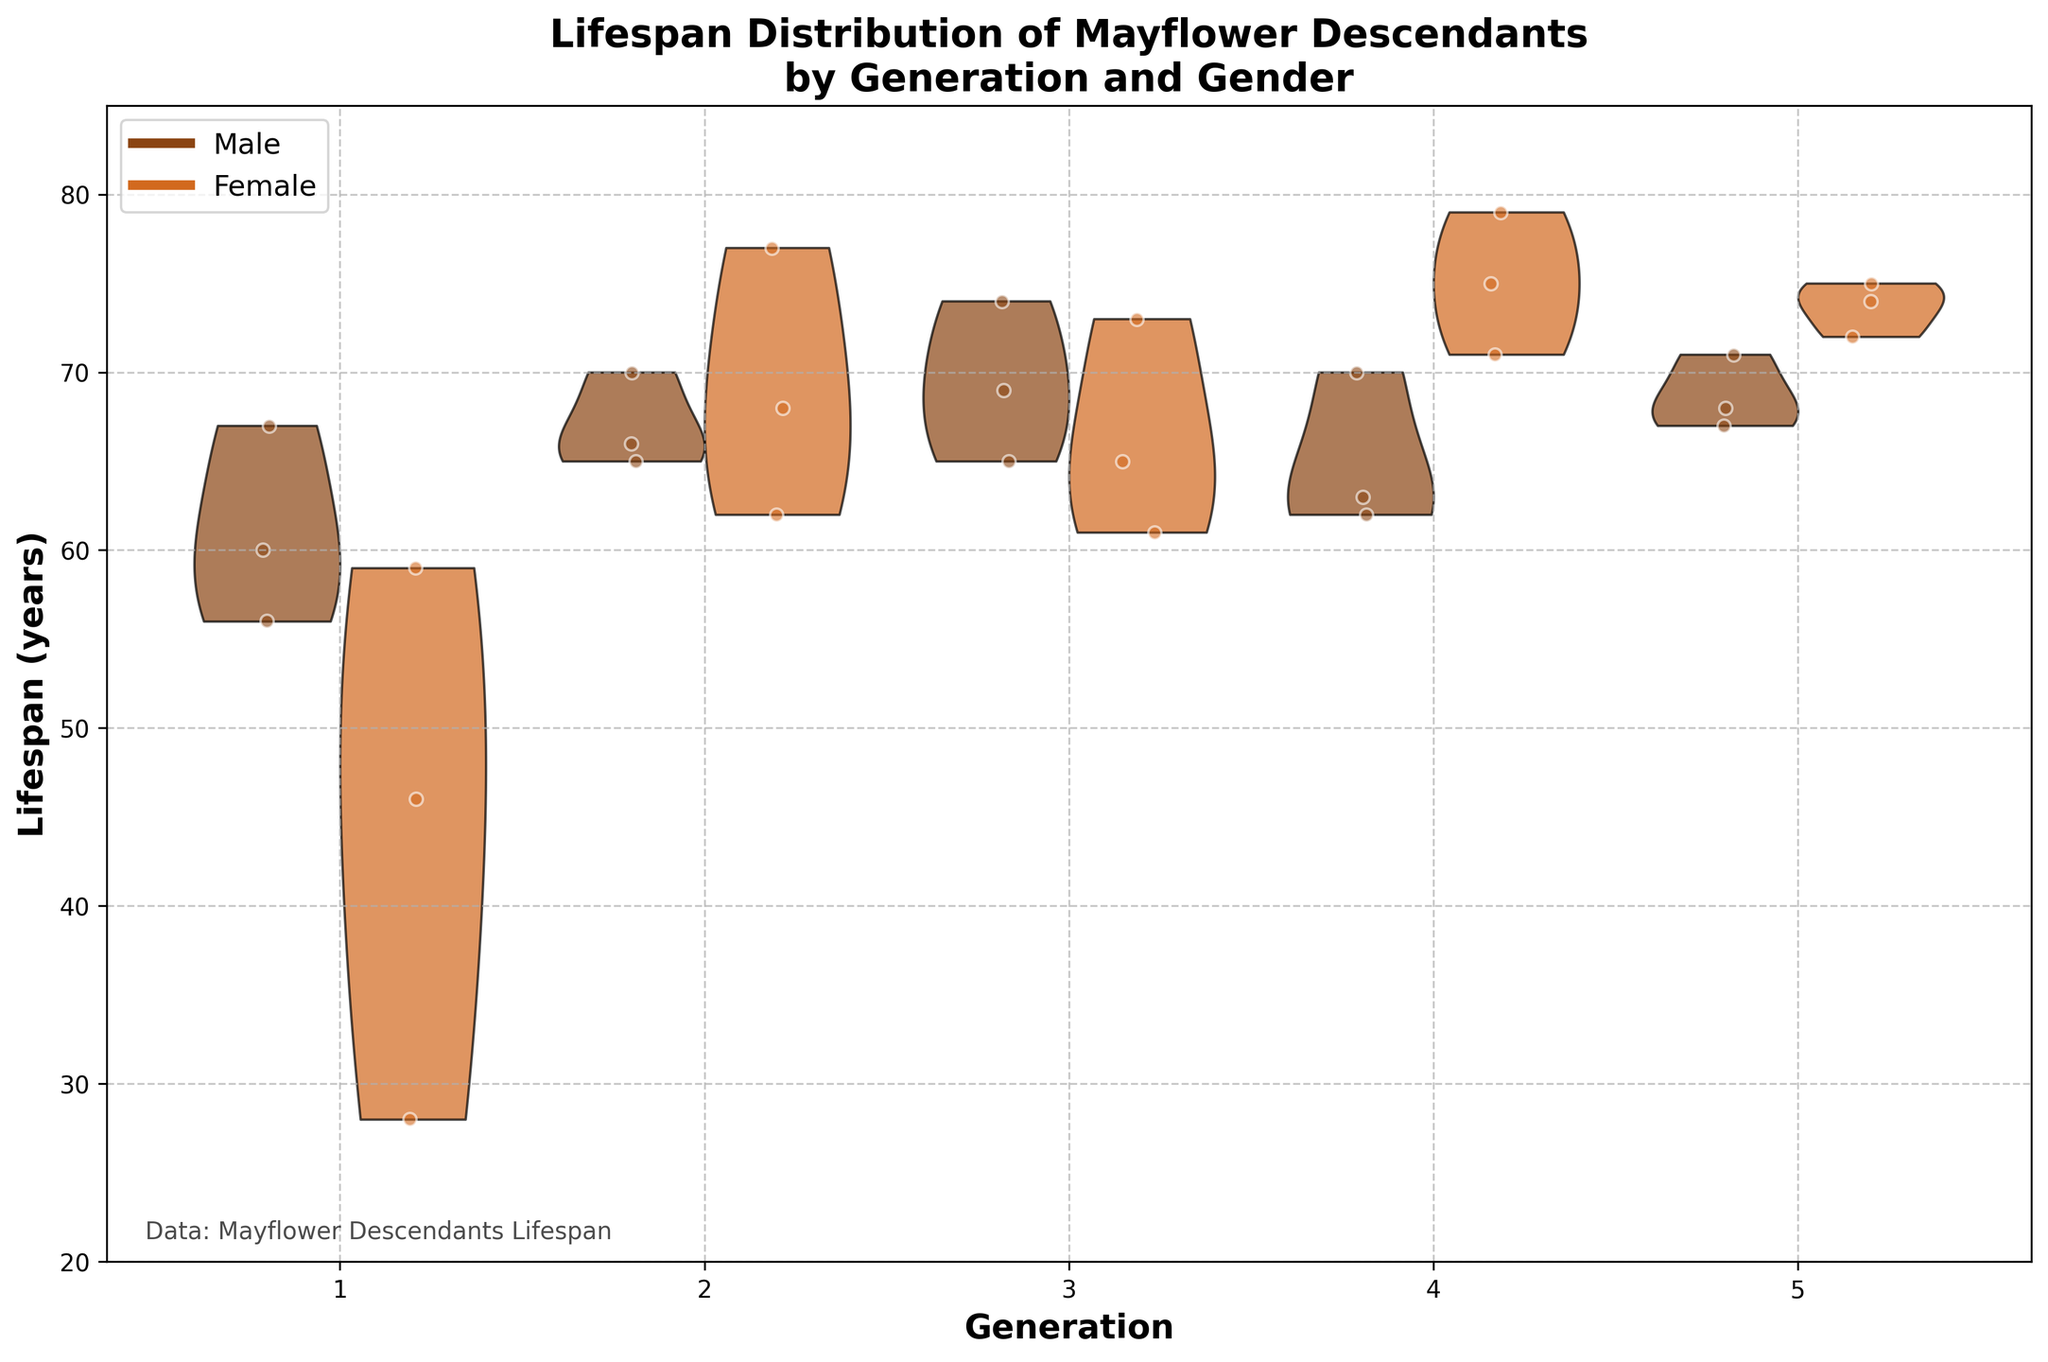What is the title of the plot? The title of the plot is prominently displayed at the top of the figure. It reads "Lifespan Distribution of Mayflower Descendants by Generation and Gender."
Answer: Lifespan Distribution of Mayflower Descendants by Generation and Gender How many generations are displayed on the x-axis? The x-axis labels each generation, starting from 1 and ending at 5, indicating that there are five generations included in the plot.
Answer: 5 Which generation has the highest median lifespan for females? By examining the distribution of the lifespan for females across each generation, the plot shows that Generation 4 has the highest median lifespan. This is suggested by the highest central peak in the female part of the violin plot for Generation 4.
Answer: Generation 4 In which generation do males have a higher median lifespan compared to females? Looking at the central peaks of the violin plots for both genders, one can identify that Generation 1 has a higher median lifespan for males compared to females based on the position of the peaks.
Answer: Generation 1 How do the lifespans of male and female descendants compare in Generation 3? By comparing the violin plots for Generation 3, both male and female lifespans seem to have a similar distribution with close medians, but the peaks for both genders are almost aligned, suggesting a similar median lifespan.
Answer: Similar On average, do males or females live longer across all generations? By visually assessing the center of each violin for both genders across all generations, females generally appear to have a higher central tendency (median) than males. This can be concluded by slightly higher peaks for females in many generations.
Answer: Females Which gender shows greater variability in lifespan in Generation 5? The width of the violin plot indicates variability. For Generation 5, the female lifespan distribution is wider, indicating greater variability compared to males.
Answer: Females Are there any outliers present in Generation 2 for both genders? The scatter plots overlaying the violin plots show individual data points. In Generation 2, both genders’ data points fall within the range of the violins without any extreme values visibly far from the distribution, indicating no clear outliers.
Answer: No What is the range of lifespans for males in Generation 4? By examining the male section of the violin plot in Generation 4, the range of lifespans spans from approximately 60 to 70 years.
Answer: 60-70 years 